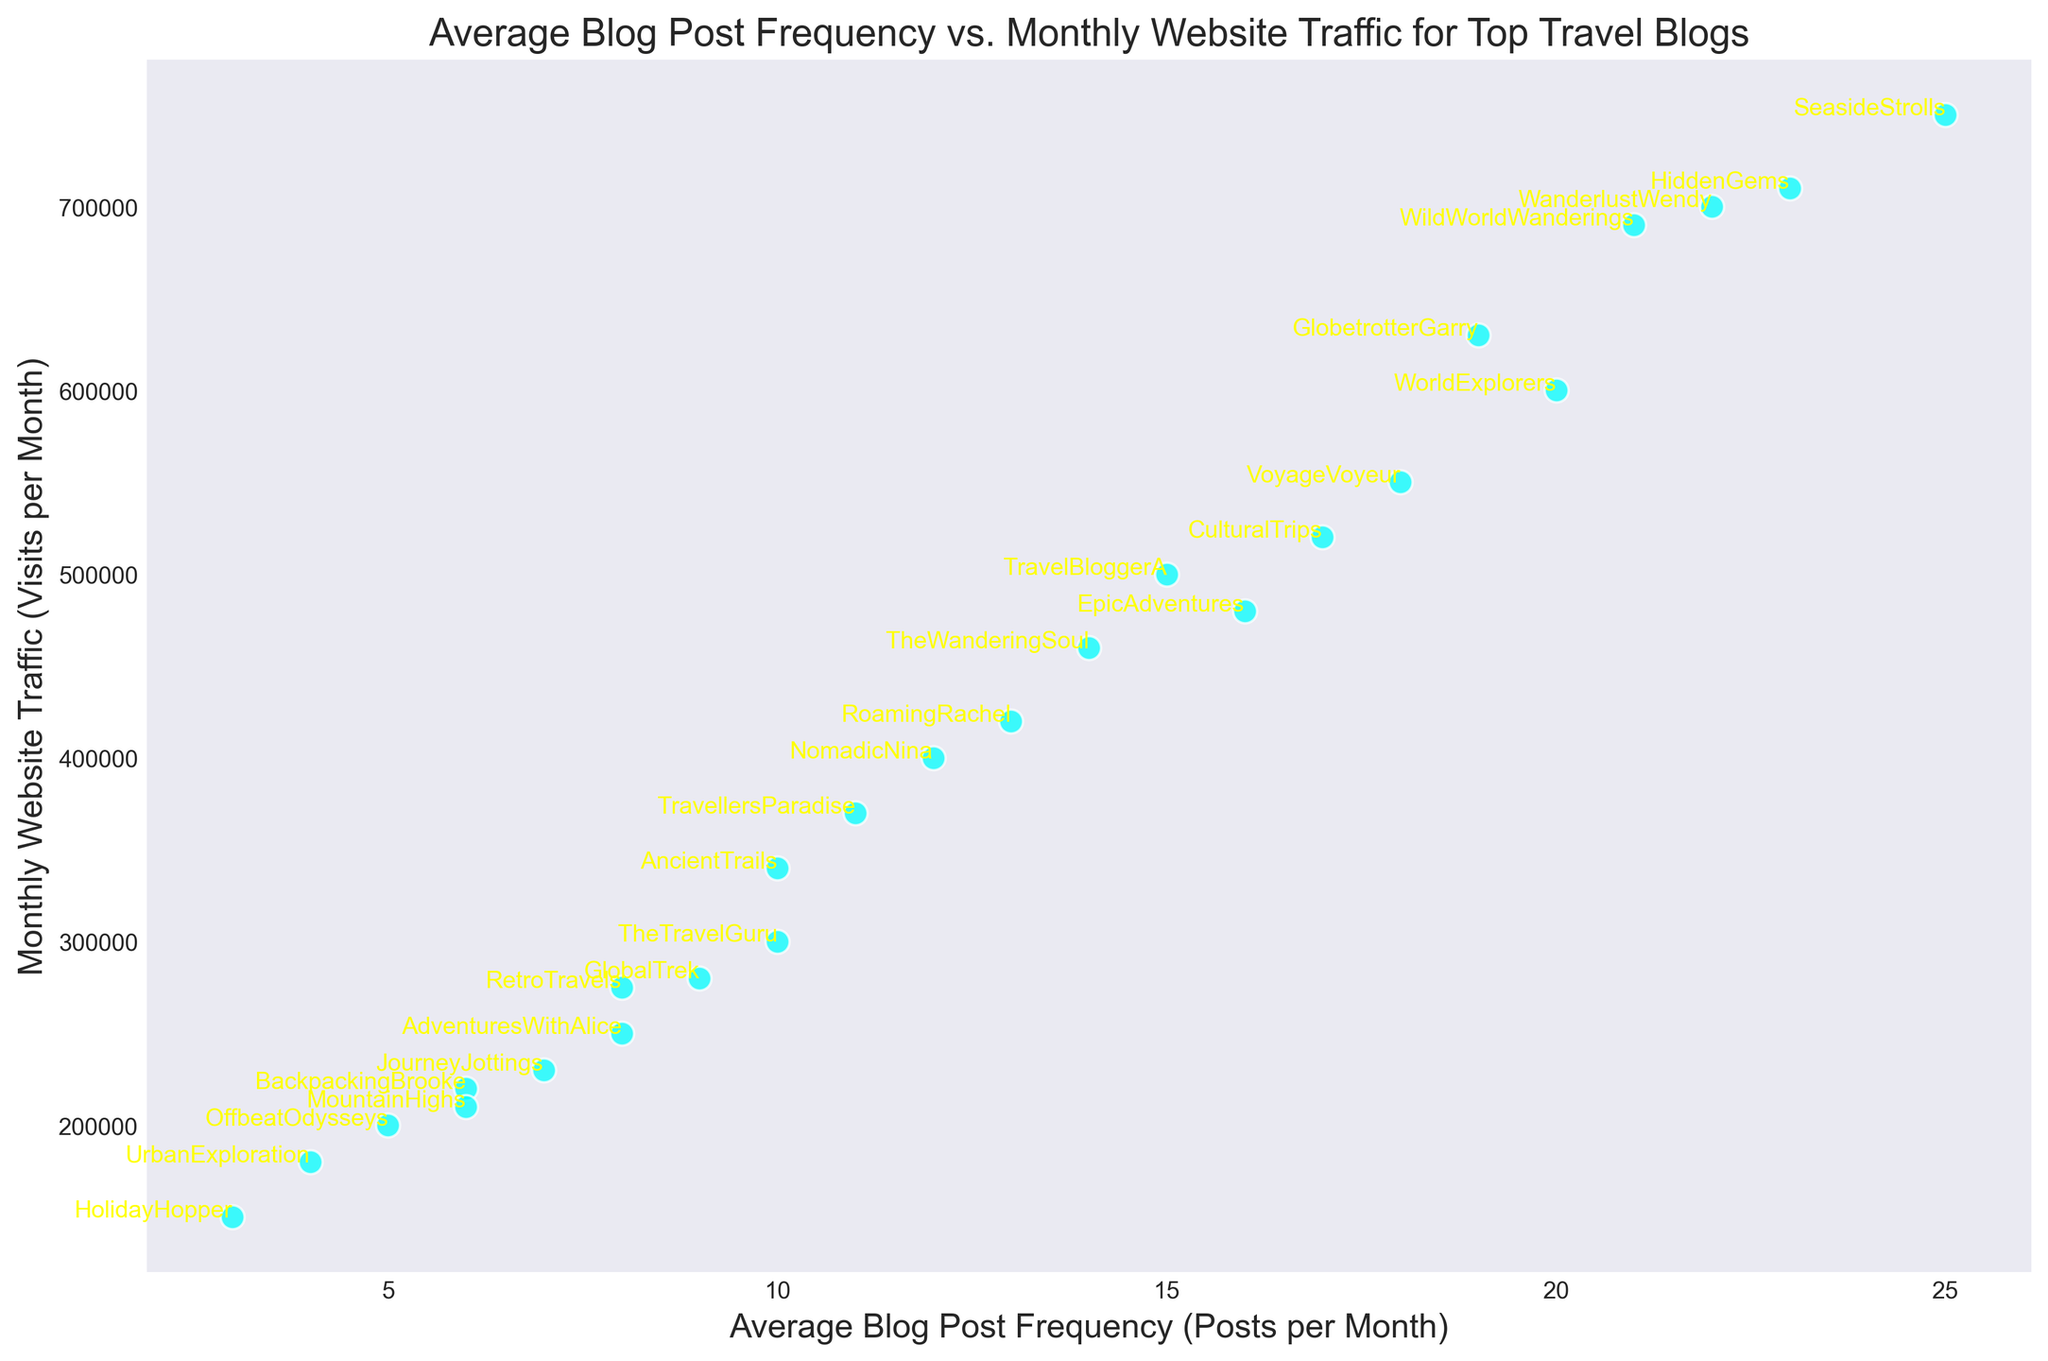Which blog has the highest monthly website traffic? By looking at the scatter plot, find the point that is positioned highest on the y-axis. SeasideStrolls is situated at the highest point on the Y-axis, indicating the highest monthly website traffic.
Answer: SeasideStrolls What is the average blog post frequency of all the blogs? Calculate the sum of all the average blog post frequencies and divide by the number of blogs. The frequencies are: 15+10+8+20+12+18+22+9+7+16+11+14+6+13+17+23+19+5+21+4+25+10+3+8+6. The sum is 317. There are 25 blogs, so the average is 317/25 = 12.68 posts per month.
Answer: 12.68 How does the post frequency for SeasideStrolls compare with that of WanderlustWendy? Look at the x-values (Average Blog Post Frequency) of SeasideStrolls and WanderlustWendy. SeasideStrolls has 25 posts per month, whereas WanderlustWendy has 22 posts per month. SeasideStrolls posts more frequently than WanderlustWendy.
Answer: SeasideStrolls posts more frequently What is the website traffic difference between HiddenGems and EpicAdventures? HiddenGems has monthly website traffic of 710,000, whereas EpicAdventures has 480,000. Calculate the difference: 710,000 - 480,000 = 230,000.
Answer: 230,000 Which blogs have a higher average blog post frequency than NomadicNina? NomadicNina has an average of 12 posts per month. Identify and list all blogs with a higher frequency: TravelBloggerA (15), WorldExplorers (20), VoyageVoyeur (18), WanderlustWendy (22), TheWanderingSoul (14), RoamingRachel (13), CulturalTrips (17), HiddenGems (23), GlobetrotterGarry (19), WildWorldWanderings (21), SeasideStrolls (25).
Answer: TravelBloggerA, WorldExplorers, VoyageVoyeur, WanderlustWendy, TheWanderingSoul, RoamingRachel, CulturalTrips, HiddenGems, GlobetrotterGarry, WildWorldWanderings, SeasideStrolls Are there any blogs that post less frequently than OffbeatOdysseys but have higher monthly website traffic? OffbeatOdysseys posts 5 times per month. Search for blogs with fewer than 5 posts per month and compare their website traffic. UrbanExploration (4 posts/month, 180,000 visits/month) and HolidayHopper (3 posts/month, 150,000 visits/month) both have lower traffic. There are no blogs that post less frequently but have higher traffic.
Answer: No Which blog has the closest blog post frequency to TravelBloggerA but higher monthly traffic? TravelBloggerA has a post frequency of 15. Look for blogs close to this frequency and higher traffic. The options close to 15 posts/month: EpicAdventures (16 posts/month, 480,000 visits/month). EpicAdventures has higher traffic.
Answer: EpicAdventures What visual attribute distinguishes SeasideStrolls from the other blogs? Identify any unique visual marker in the scatter plot. SeasideStrolls is annotated and is positioned at the topmost right corner of the scatter plot, indicating the highest average blog post frequency and monthly website traffic.
Answer: Topmost right corner annotation What is the correlation between average blog post frequency and monthly website traffic? Observe the general trend of the scatter plot points. As the x-axis (average blog post frequency) increases, the y-axis (monthly website traffic) also tends to increase, indicating a positive correlation.
Answer: Positive correlation 